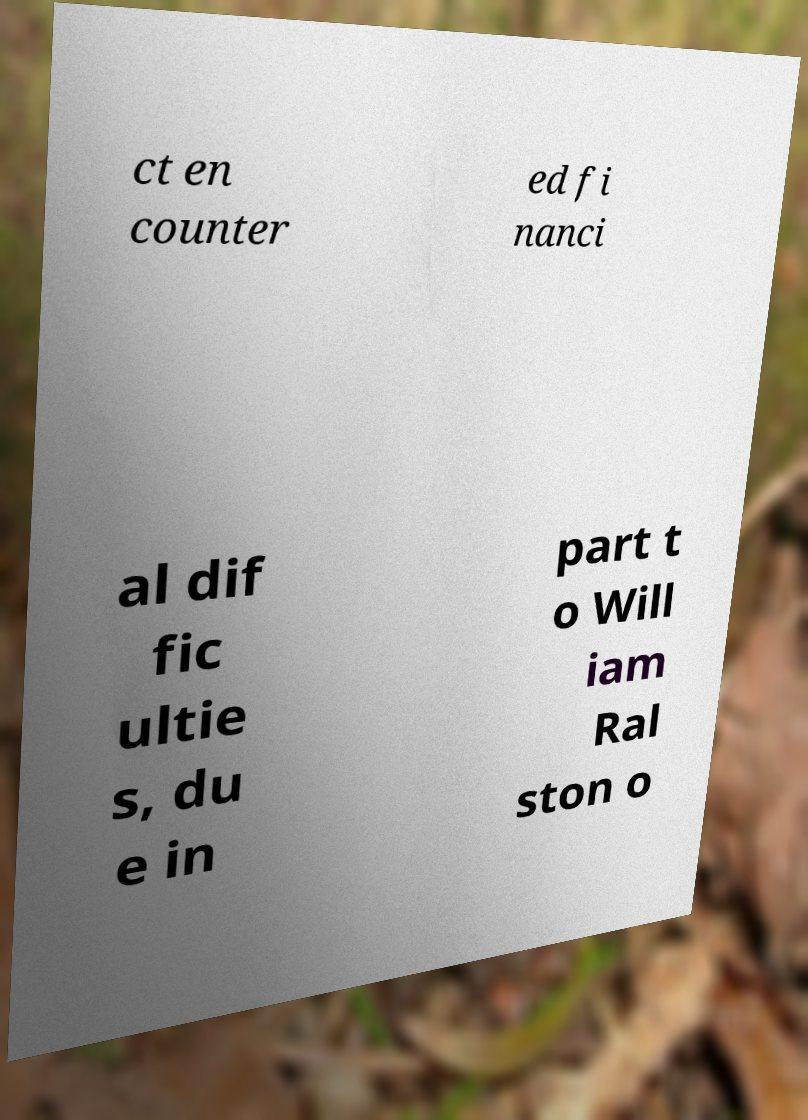What messages or text are displayed in this image? I need them in a readable, typed format. ct en counter ed fi nanci al dif fic ultie s, du e in part t o Will iam Ral ston o 